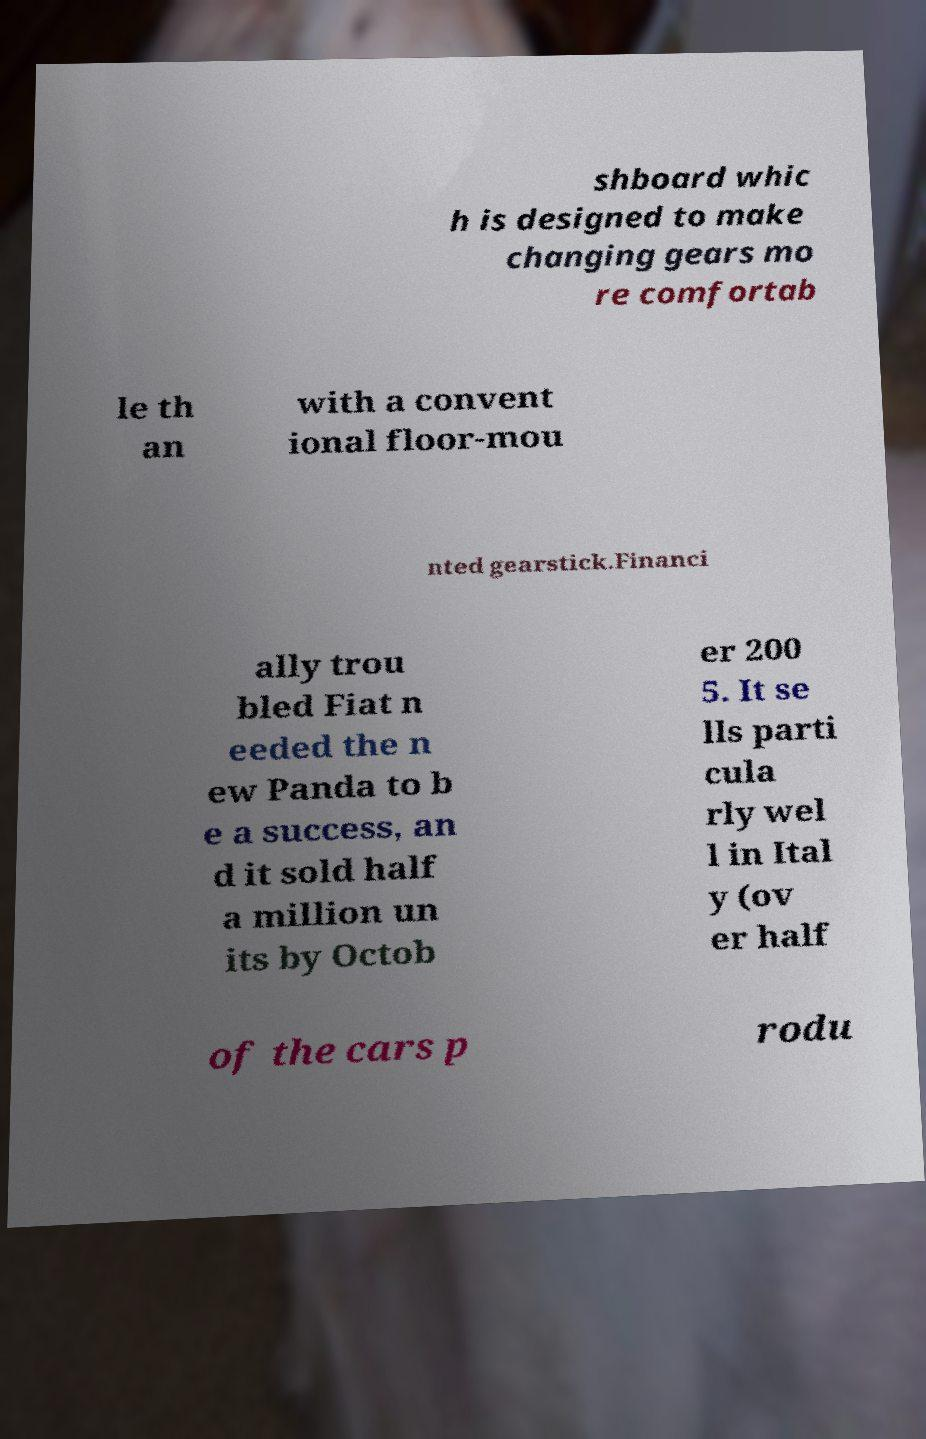For documentation purposes, I need the text within this image transcribed. Could you provide that? shboard whic h is designed to make changing gears mo re comfortab le th an with a convent ional floor-mou nted gearstick.Financi ally trou bled Fiat n eeded the n ew Panda to b e a success, an d it sold half a million un its by Octob er 200 5. It se lls parti cula rly wel l in Ital y (ov er half of the cars p rodu 